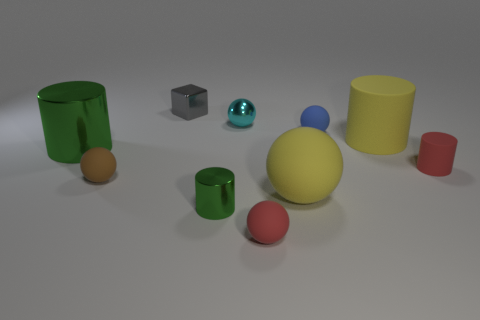Subtract all blocks. How many objects are left? 9 Add 4 large rubber spheres. How many large rubber spheres are left? 5 Add 9 brown objects. How many brown objects exist? 10 Subtract all yellow cylinders. How many cylinders are left? 3 Subtract all red rubber balls. How many balls are left? 4 Subtract 0 purple balls. How many objects are left? 10 Subtract 2 balls. How many balls are left? 3 Subtract all blue cylinders. Subtract all yellow cubes. How many cylinders are left? 4 Subtract all green cubes. How many brown cylinders are left? 0 Subtract all tiny red rubber objects. Subtract all tiny brown rubber spheres. How many objects are left? 7 